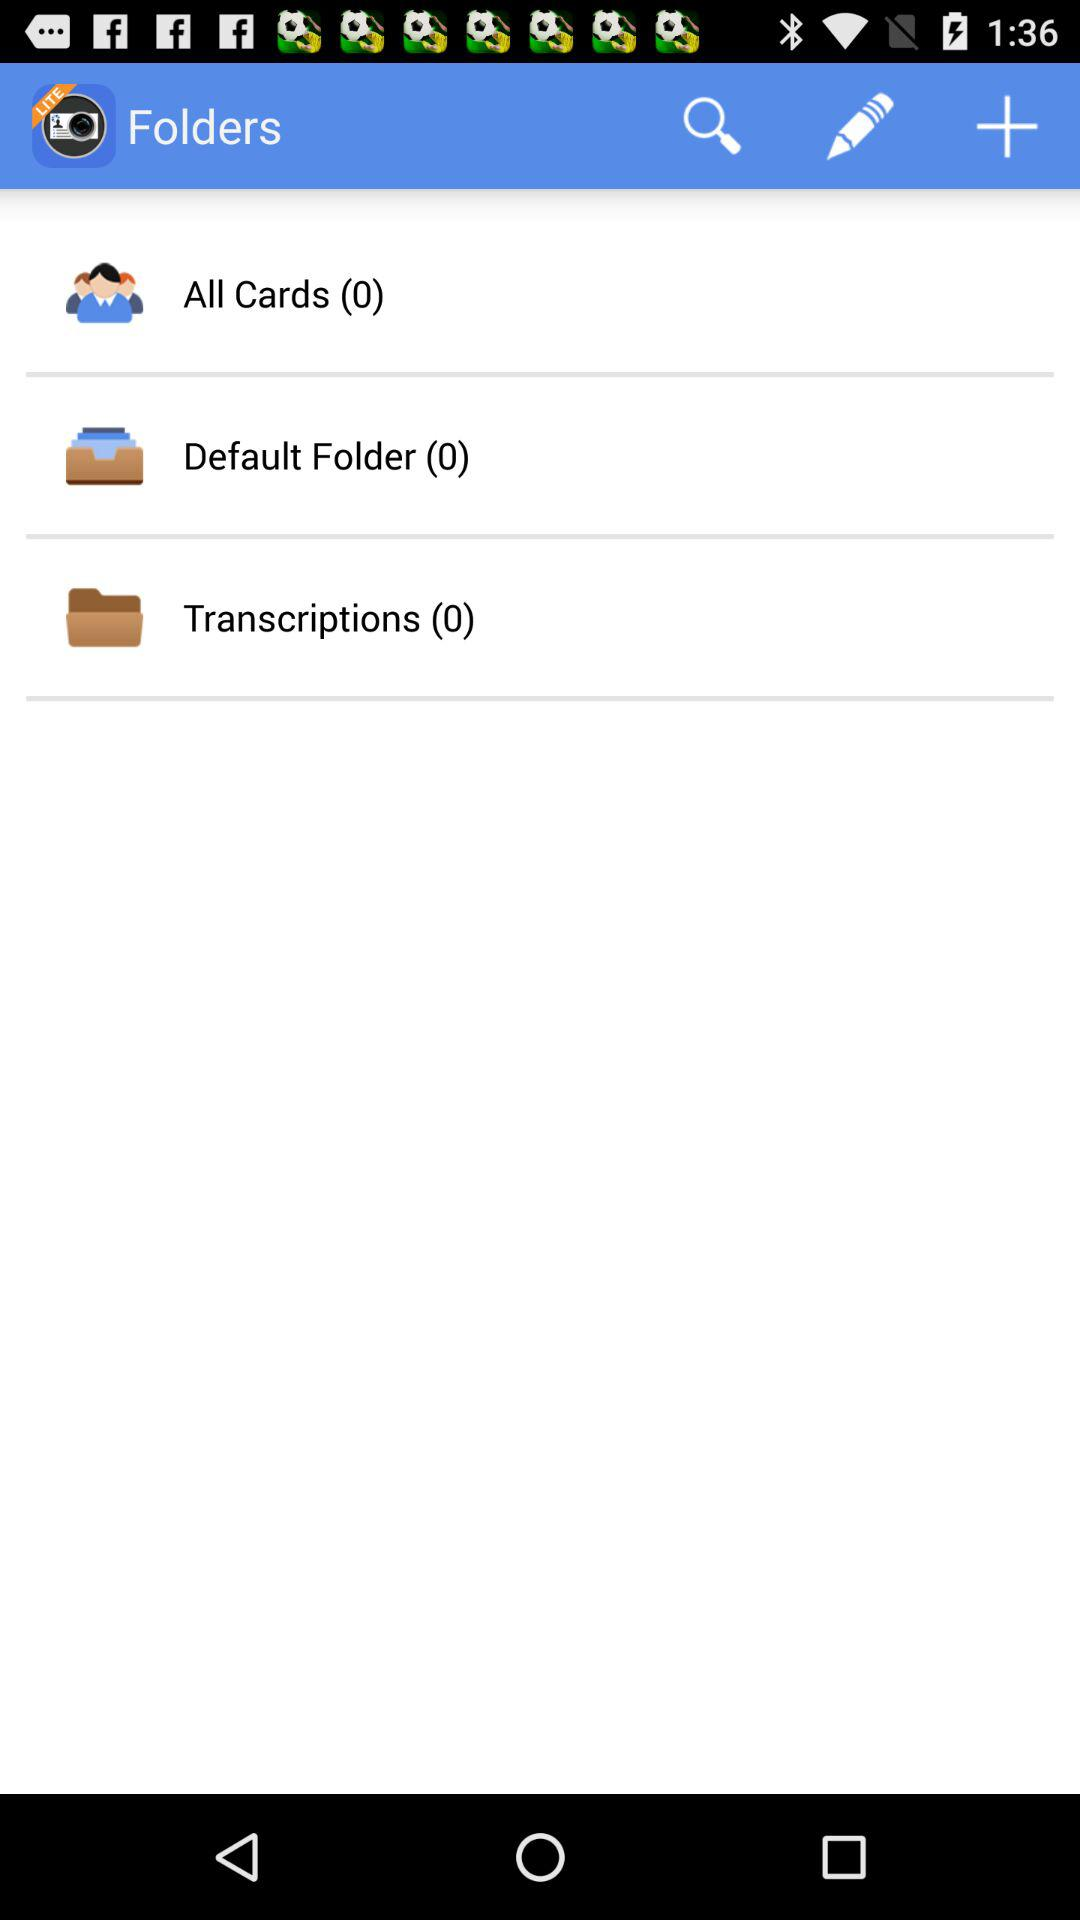How many folders are there?
Answer the question using a single word or phrase. 3 